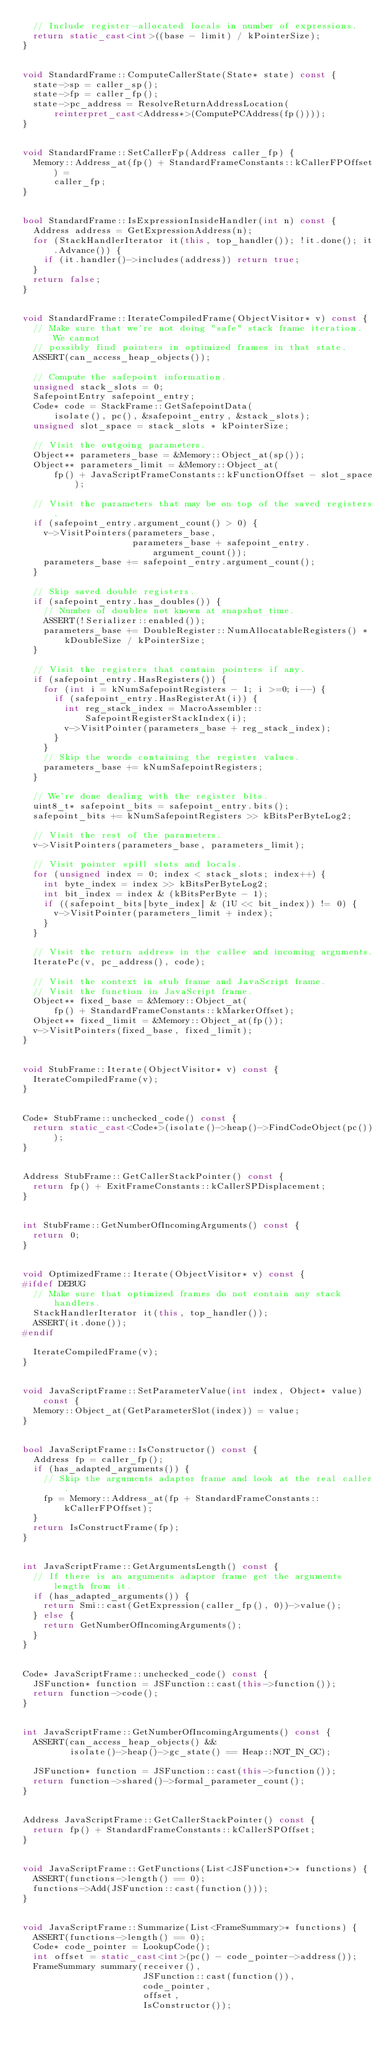<code> <loc_0><loc_0><loc_500><loc_500><_C++_>  // Include register-allocated locals in number of expressions.
  return static_cast<int>((base - limit) / kPointerSize);
}


void StandardFrame::ComputeCallerState(State* state) const {
  state->sp = caller_sp();
  state->fp = caller_fp();
  state->pc_address = ResolveReturnAddressLocation(
      reinterpret_cast<Address*>(ComputePCAddress(fp())));
}


void StandardFrame::SetCallerFp(Address caller_fp) {
  Memory::Address_at(fp() + StandardFrameConstants::kCallerFPOffset) =
      caller_fp;
}


bool StandardFrame::IsExpressionInsideHandler(int n) const {
  Address address = GetExpressionAddress(n);
  for (StackHandlerIterator it(this, top_handler()); !it.done(); it.Advance()) {
    if (it.handler()->includes(address)) return true;
  }
  return false;
}


void StandardFrame::IterateCompiledFrame(ObjectVisitor* v) const {
  // Make sure that we're not doing "safe" stack frame iteration. We cannot
  // possibly find pointers in optimized frames in that state.
  ASSERT(can_access_heap_objects());

  // Compute the safepoint information.
  unsigned stack_slots = 0;
  SafepointEntry safepoint_entry;
  Code* code = StackFrame::GetSafepointData(
      isolate(), pc(), &safepoint_entry, &stack_slots);
  unsigned slot_space = stack_slots * kPointerSize;

  // Visit the outgoing parameters.
  Object** parameters_base = &Memory::Object_at(sp());
  Object** parameters_limit = &Memory::Object_at(
      fp() + JavaScriptFrameConstants::kFunctionOffset - slot_space);

  // Visit the parameters that may be on top of the saved registers.
  if (safepoint_entry.argument_count() > 0) {
    v->VisitPointers(parameters_base,
                     parameters_base + safepoint_entry.argument_count());
    parameters_base += safepoint_entry.argument_count();
  }

  // Skip saved double registers.
  if (safepoint_entry.has_doubles()) {
    // Number of doubles not known at snapshot time.
    ASSERT(!Serializer::enabled());
    parameters_base += DoubleRegister::NumAllocatableRegisters() *
        kDoubleSize / kPointerSize;
  }

  // Visit the registers that contain pointers if any.
  if (safepoint_entry.HasRegisters()) {
    for (int i = kNumSafepointRegisters - 1; i >=0; i--) {
      if (safepoint_entry.HasRegisterAt(i)) {
        int reg_stack_index = MacroAssembler::SafepointRegisterStackIndex(i);
        v->VisitPointer(parameters_base + reg_stack_index);
      }
    }
    // Skip the words containing the register values.
    parameters_base += kNumSafepointRegisters;
  }

  // We're done dealing with the register bits.
  uint8_t* safepoint_bits = safepoint_entry.bits();
  safepoint_bits += kNumSafepointRegisters >> kBitsPerByteLog2;

  // Visit the rest of the parameters.
  v->VisitPointers(parameters_base, parameters_limit);

  // Visit pointer spill slots and locals.
  for (unsigned index = 0; index < stack_slots; index++) {
    int byte_index = index >> kBitsPerByteLog2;
    int bit_index = index & (kBitsPerByte - 1);
    if ((safepoint_bits[byte_index] & (1U << bit_index)) != 0) {
      v->VisitPointer(parameters_limit + index);
    }
  }

  // Visit the return address in the callee and incoming arguments.
  IteratePc(v, pc_address(), code);

  // Visit the context in stub frame and JavaScript frame.
  // Visit the function in JavaScript frame.
  Object** fixed_base = &Memory::Object_at(
      fp() + StandardFrameConstants::kMarkerOffset);
  Object** fixed_limit = &Memory::Object_at(fp());
  v->VisitPointers(fixed_base, fixed_limit);
}


void StubFrame::Iterate(ObjectVisitor* v) const {
  IterateCompiledFrame(v);
}


Code* StubFrame::unchecked_code() const {
  return static_cast<Code*>(isolate()->heap()->FindCodeObject(pc()));
}


Address StubFrame::GetCallerStackPointer() const {
  return fp() + ExitFrameConstants::kCallerSPDisplacement;
}


int StubFrame::GetNumberOfIncomingArguments() const {
  return 0;
}


void OptimizedFrame::Iterate(ObjectVisitor* v) const {
#ifdef DEBUG
  // Make sure that optimized frames do not contain any stack handlers.
  StackHandlerIterator it(this, top_handler());
  ASSERT(it.done());
#endif

  IterateCompiledFrame(v);
}


void JavaScriptFrame::SetParameterValue(int index, Object* value) const {
  Memory::Object_at(GetParameterSlot(index)) = value;
}


bool JavaScriptFrame::IsConstructor() const {
  Address fp = caller_fp();
  if (has_adapted_arguments()) {
    // Skip the arguments adaptor frame and look at the real caller.
    fp = Memory::Address_at(fp + StandardFrameConstants::kCallerFPOffset);
  }
  return IsConstructFrame(fp);
}


int JavaScriptFrame::GetArgumentsLength() const {
  // If there is an arguments adaptor frame get the arguments length from it.
  if (has_adapted_arguments()) {
    return Smi::cast(GetExpression(caller_fp(), 0))->value();
  } else {
    return GetNumberOfIncomingArguments();
  }
}


Code* JavaScriptFrame::unchecked_code() const {
  JSFunction* function = JSFunction::cast(this->function());
  return function->code();
}


int JavaScriptFrame::GetNumberOfIncomingArguments() const {
  ASSERT(can_access_heap_objects() &&
         isolate()->heap()->gc_state() == Heap::NOT_IN_GC);

  JSFunction* function = JSFunction::cast(this->function());
  return function->shared()->formal_parameter_count();
}


Address JavaScriptFrame::GetCallerStackPointer() const {
  return fp() + StandardFrameConstants::kCallerSPOffset;
}


void JavaScriptFrame::GetFunctions(List<JSFunction*>* functions) {
  ASSERT(functions->length() == 0);
  functions->Add(JSFunction::cast(function()));
}


void JavaScriptFrame::Summarize(List<FrameSummary>* functions) {
  ASSERT(functions->length() == 0);
  Code* code_pointer = LookupCode();
  int offset = static_cast<int>(pc() - code_pointer->address());
  FrameSummary summary(receiver(),
                       JSFunction::cast(function()),
                       code_pointer,
                       offset,
                       IsConstructor());</code> 